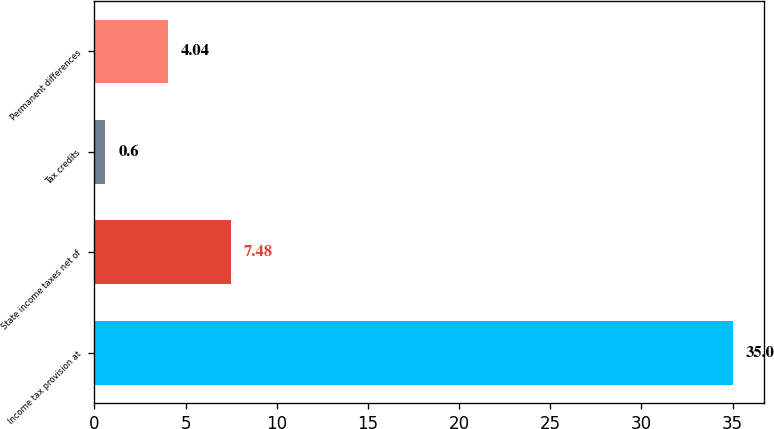Convert chart to OTSL. <chart><loc_0><loc_0><loc_500><loc_500><bar_chart><fcel>Income tax provision at<fcel>State income taxes net of<fcel>Tax credits<fcel>Permanent differences<nl><fcel>35<fcel>7.48<fcel>0.6<fcel>4.04<nl></chart> 